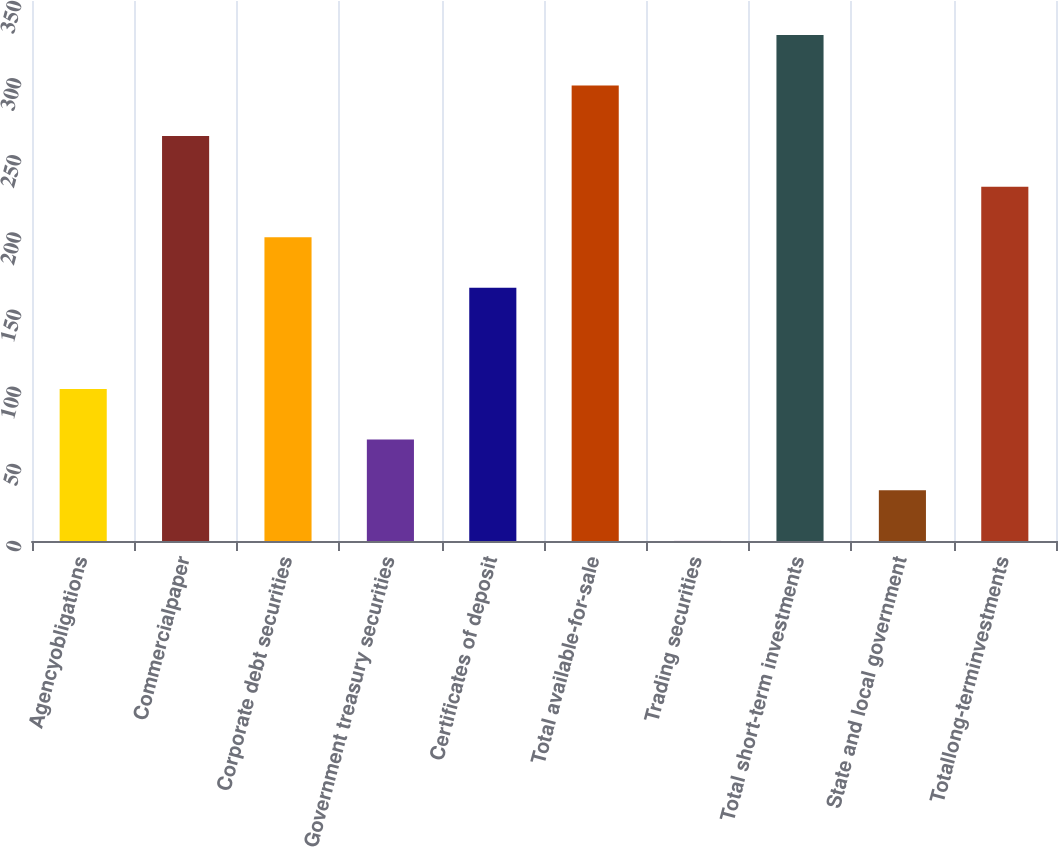Convert chart. <chart><loc_0><loc_0><loc_500><loc_500><bar_chart><fcel>Agencyobligations<fcel>Commercialpaper<fcel>Corporate debt securities<fcel>Government treasury securities<fcel>Certificates of deposit<fcel>Total available-for-sale<fcel>Trading securities<fcel>Total short-term investments<fcel>State and local government<fcel>Totallong-terminvestments<nl><fcel>98.51<fcel>262.46<fcel>196.88<fcel>65.72<fcel>164.09<fcel>295.25<fcel>0.14<fcel>328.04<fcel>32.93<fcel>229.67<nl></chart> 